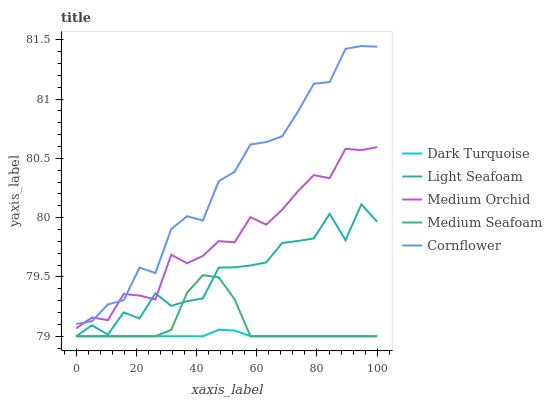Does Dark Turquoise have the minimum area under the curve?
Answer yes or no. Yes. Does Cornflower have the maximum area under the curve?
Answer yes or no. Yes. Does Medium Orchid have the minimum area under the curve?
Answer yes or no. No. Does Medium Orchid have the maximum area under the curve?
Answer yes or no. No. Is Dark Turquoise the smoothest?
Answer yes or no. Yes. Is Light Seafoam the roughest?
Answer yes or no. Yes. Is Medium Orchid the smoothest?
Answer yes or no. No. Is Medium Orchid the roughest?
Answer yes or no. No. Does Medium Orchid have the lowest value?
Answer yes or no. No. Does Medium Orchid have the highest value?
Answer yes or no. No. Is Medium Seafoam less than Cornflower?
Answer yes or no. Yes. Is Cornflower greater than Light Seafoam?
Answer yes or no. Yes. Does Medium Seafoam intersect Cornflower?
Answer yes or no. No. 